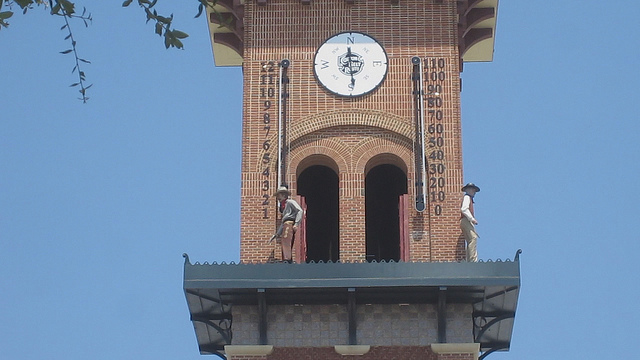What might be the historical or cultural importance of such clocks in public spaces? Public clocks have significant historical and cultural importance. They often serve as focal points in the urban landscape, symbolizing communal harmony and the importance of time in social life. Historically, such clocks affirmed technological advancements and civic pride, as municipalities competed to erect timepieces that were accurate and visually striking. They often mark the center of activity in a town or city, and can be points for social gatherings, navigation landmarks, and icons of local heritage. 